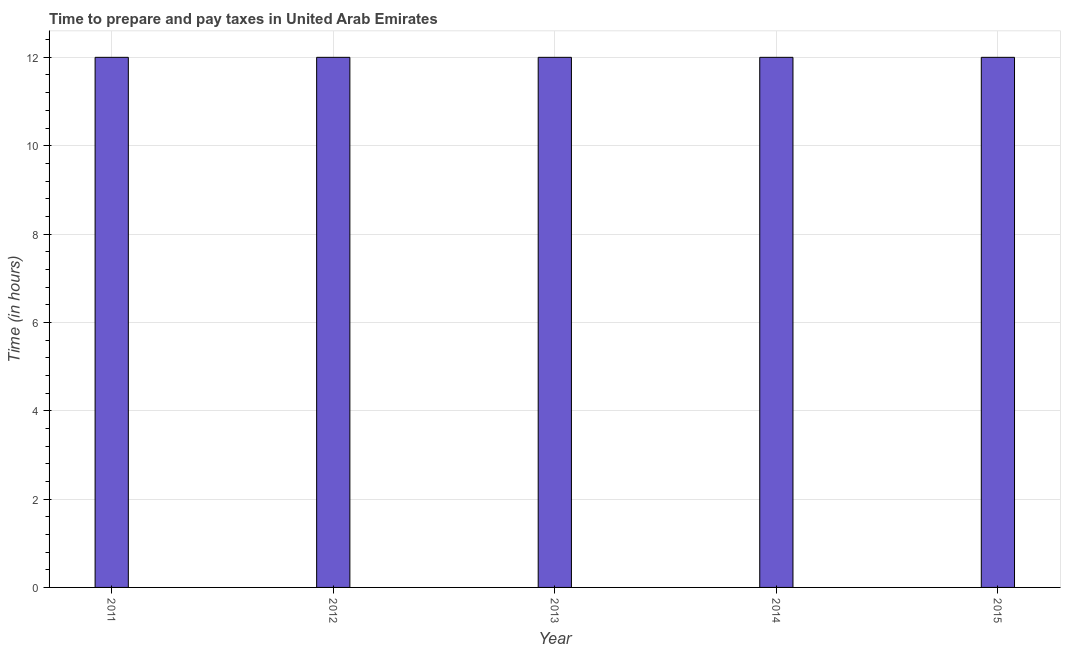Does the graph contain any zero values?
Provide a succinct answer. No. Does the graph contain grids?
Keep it short and to the point. Yes. What is the title of the graph?
Your response must be concise. Time to prepare and pay taxes in United Arab Emirates. What is the label or title of the X-axis?
Keep it short and to the point. Year. What is the label or title of the Y-axis?
Your response must be concise. Time (in hours). Across all years, what is the maximum time to prepare and pay taxes?
Make the answer very short. 12. In which year was the time to prepare and pay taxes maximum?
Make the answer very short. 2011. In which year was the time to prepare and pay taxes minimum?
Offer a terse response. 2011. What is the sum of the time to prepare and pay taxes?
Provide a succinct answer. 60. Do a majority of the years between 2015 and 2013 (inclusive) have time to prepare and pay taxes greater than 10 hours?
Give a very brief answer. Yes. Is the sum of the time to prepare and pay taxes in 2012 and 2013 greater than the maximum time to prepare and pay taxes across all years?
Your answer should be very brief. Yes. What is the difference between the highest and the lowest time to prepare and pay taxes?
Offer a terse response. 0. Are all the bars in the graph horizontal?
Offer a very short reply. No. What is the difference between two consecutive major ticks on the Y-axis?
Offer a terse response. 2. Are the values on the major ticks of Y-axis written in scientific E-notation?
Provide a short and direct response. No. What is the Time (in hours) in 2011?
Provide a short and direct response. 12. What is the Time (in hours) in 2014?
Your response must be concise. 12. What is the difference between the Time (in hours) in 2011 and 2012?
Your answer should be compact. 0. What is the difference between the Time (in hours) in 2011 and 2013?
Provide a succinct answer. 0. What is the difference between the Time (in hours) in 2011 and 2014?
Your answer should be compact. 0. What is the difference between the Time (in hours) in 2013 and 2014?
Offer a very short reply. 0. What is the difference between the Time (in hours) in 2013 and 2015?
Your answer should be very brief. 0. What is the ratio of the Time (in hours) in 2011 to that in 2012?
Make the answer very short. 1. What is the ratio of the Time (in hours) in 2011 to that in 2014?
Ensure brevity in your answer.  1. What is the ratio of the Time (in hours) in 2012 to that in 2013?
Offer a very short reply. 1. What is the ratio of the Time (in hours) in 2013 to that in 2014?
Offer a very short reply. 1. What is the ratio of the Time (in hours) in 2013 to that in 2015?
Your answer should be very brief. 1. What is the ratio of the Time (in hours) in 2014 to that in 2015?
Provide a short and direct response. 1. 